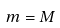Convert formula to latex. <formula><loc_0><loc_0><loc_500><loc_500>m = M</formula> 